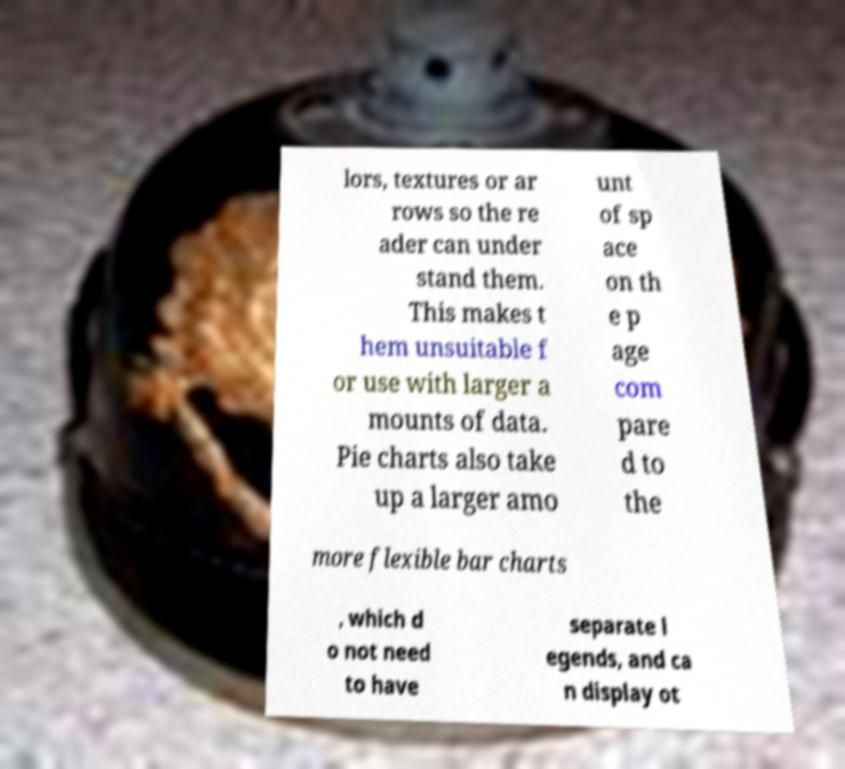There's text embedded in this image that I need extracted. Can you transcribe it verbatim? lors, textures or ar rows so the re ader can under stand them. This makes t hem unsuitable f or use with larger a mounts of data. Pie charts also take up a larger amo unt of sp ace on th e p age com pare d to the more flexible bar charts , which d o not need to have separate l egends, and ca n display ot 